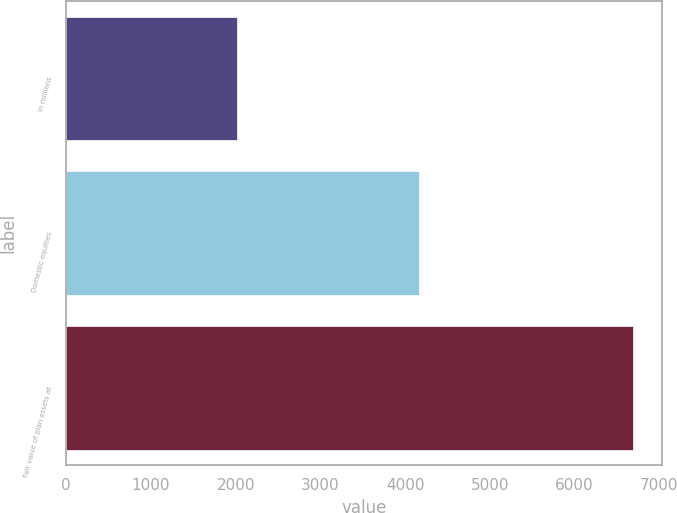Convert chart. <chart><loc_0><loc_0><loc_500><loc_500><bar_chart><fcel>in millions<fcel>Domestic equities<fcel>Fair value of plan assets at<nl><fcel>2013<fcel>4163<fcel>6694<nl></chart> 